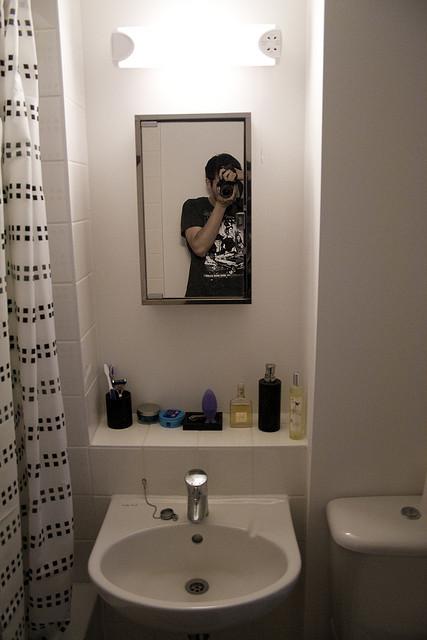How many toothbrushes are in the picture?
Keep it brief. 1. Where is the mirror?
Be succinct. Above sink. Is the man looking into the mirror?
Give a very brief answer. Yes. Which room is this?
Short answer required. Bathroom. How many bottles of cologne are there?
Quick response, please. 3. Is this room in a home?
Concise answer only. Yes. 